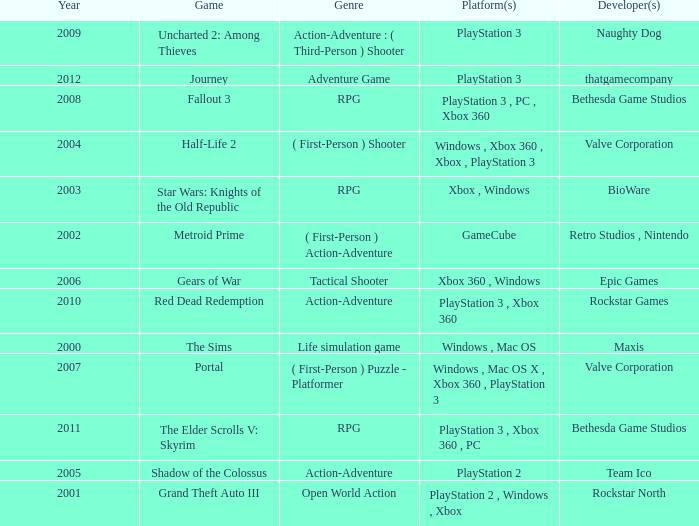What's the genre of The Sims before 2002? Life simulation game. 